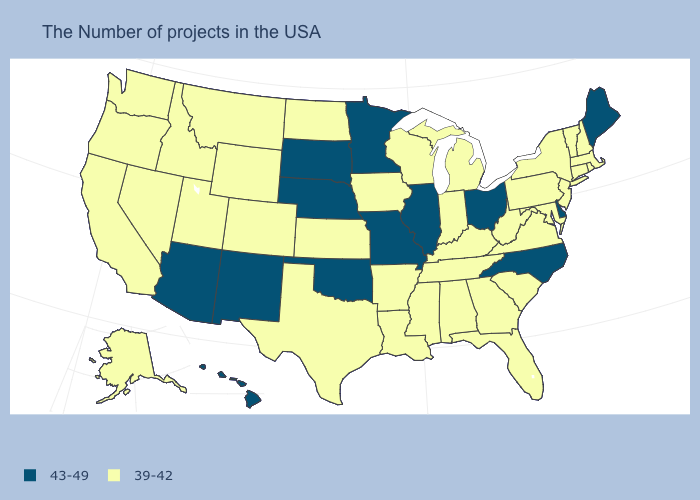What is the lowest value in the USA?
Be succinct. 39-42. What is the value of Nebraska?
Answer briefly. 43-49. Is the legend a continuous bar?
Keep it brief. No. Does Georgia have the lowest value in the USA?
Concise answer only. Yes. Among the states that border Connecticut , which have the highest value?
Short answer required. Massachusetts, Rhode Island, New York. Name the states that have a value in the range 43-49?
Quick response, please. Maine, Delaware, North Carolina, Ohio, Illinois, Missouri, Minnesota, Nebraska, Oklahoma, South Dakota, New Mexico, Arizona, Hawaii. Does Mississippi have a lower value than Connecticut?
Write a very short answer. No. Which states have the lowest value in the Northeast?
Answer briefly. Massachusetts, Rhode Island, New Hampshire, Vermont, Connecticut, New York, New Jersey, Pennsylvania. Which states have the highest value in the USA?
Keep it brief. Maine, Delaware, North Carolina, Ohio, Illinois, Missouri, Minnesota, Nebraska, Oklahoma, South Dakota, New Mexico, Arizona, Hawaii. Which states have the highest value in the USA?
Short answer required. Maine, Delaware, North Carolina, Ohio, Illinois, Missouri, Minnesota, Nebraska, Oklahoma, South Dakota, New Mexico, Arizona, Hawaii. What is the highest value in the South ?
Write a very short answer. 43-49. Does Hawaii have the same value as Illinois?
Keep it brief. Yes. Does West Virginia have a higher value than Wisconsin?
Write a very short answer. No. What is the value of South Carolina?
Quick response, please. 39-42. What is the highest value in states that border Mississippi?
Keep it brief. 39-42. 